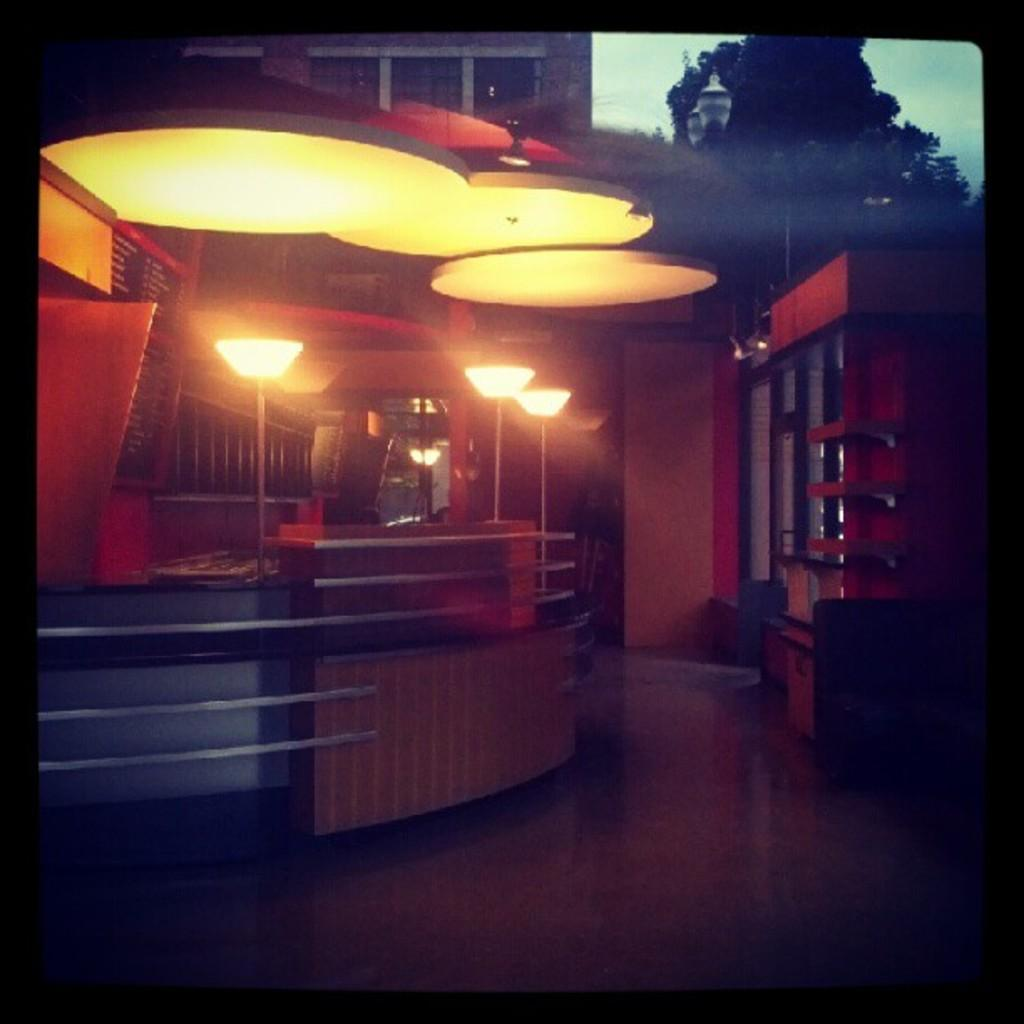What is the main object in the center of the image? There is a desk in the center of the image. What is located above the desk? There are lamps above the desk. What can be seen in the background of the image? There is a building and a tree in the background of the image. How many people are in the alley behind the building in the image? There is no alley or crowd of people visible in the image; it only shows a desk, lamps, a building, and a tree. 